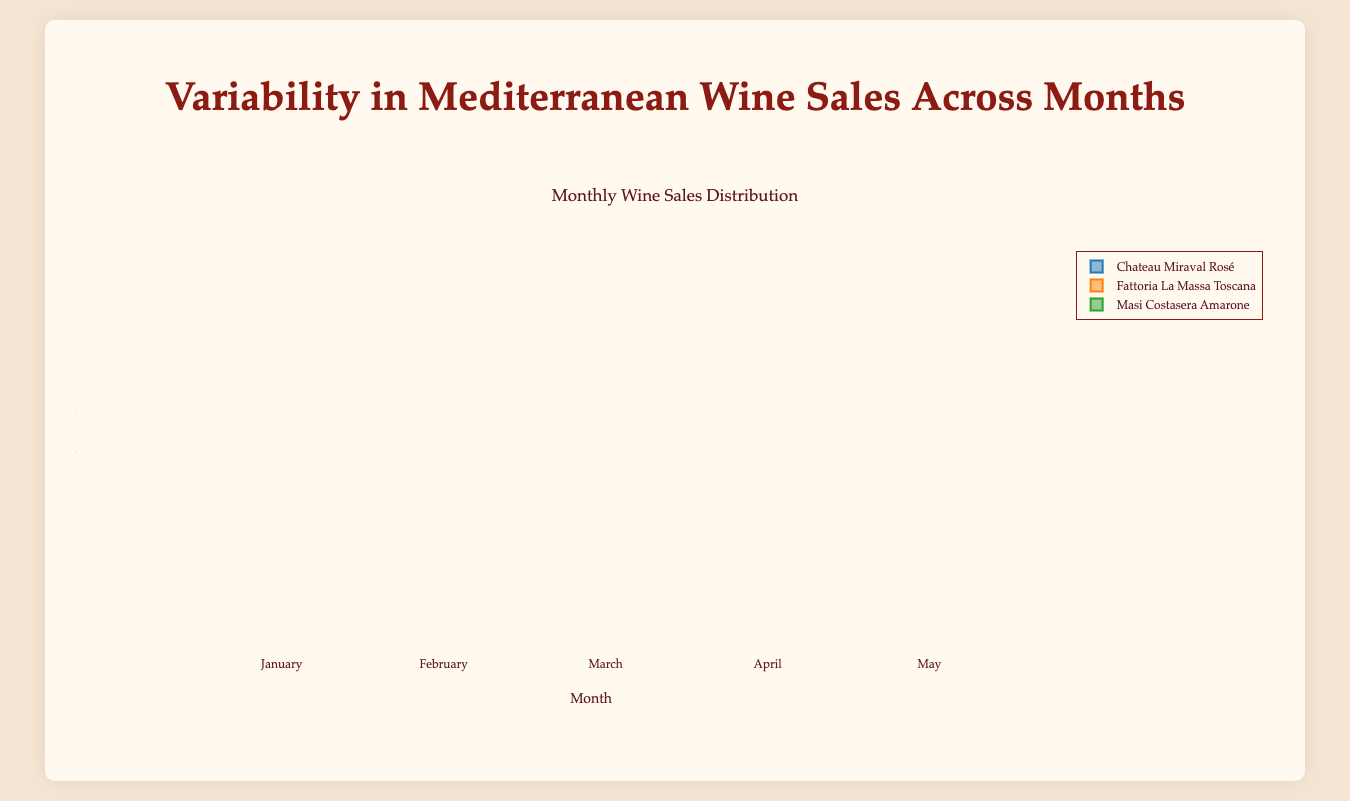Which wine had the highest average sales in August? From the box plot, observe the median positions of the wines in August. Chateau Miraval Rosé has the highest median in August, indicating it has the highest average sales.
Answer: Chateau Miraval Rosé Which month recorded the lowest sales variability for Masi Costasera Amarone? Sales variability can be inferred from the box length. The smaller the box, the lower the variability. In January, the box for Masi Costasera Amarone is the most compact, indicating the lowest sales variability.
Answer: January Compare the sales of Fattoria La Massa Toscana in March and July. Which month had higher median sales? We compare the medians for Fattoria La Massa Toscana in March and July. The median line for July is higher than that in March, so July had higher median sales.
Answer: July In which month did Chateau Miraval Rosé see the most significant increase in sales compared to the previous month? By examining the medians across months, from February to March, the median of Chateau Miraval Rosé shows the most significant increase.
Answer: March How do the sales of Fattoria La Massa Toscana differ from June to August? By comparing the box plots, we can see the median sales increase each month from June to August for Fattoria La Massa Toscana.
Answer: Increase What's the lowest median sale month for Chateau Miraval Rosé? Observe the median positions of the monthly box plots for Chateau Miraval Rosé. November has the lowest median.
Answer: November Which wine shows the most consistent sales in May? Consistency in sales can be evaluated by looking for the shortest box length in May. Masi Costasera Amarone has the shortest box, indicating the most consistent sales in May.
Answer: Masi Costasera Amarone How do the median sales of Masi Costasera Amarone in April compare to June? Compare the median lines of Masi Costasera Amarone for April and June and note that April's median is higher than June's.
Answer: Higher in April Which month has the highest sales variability for Fattoria La Massa Toscana? The largest box length indicates the highest variability. In August, Fattoria La Massa Toscana has the longest box.
Answer: August 